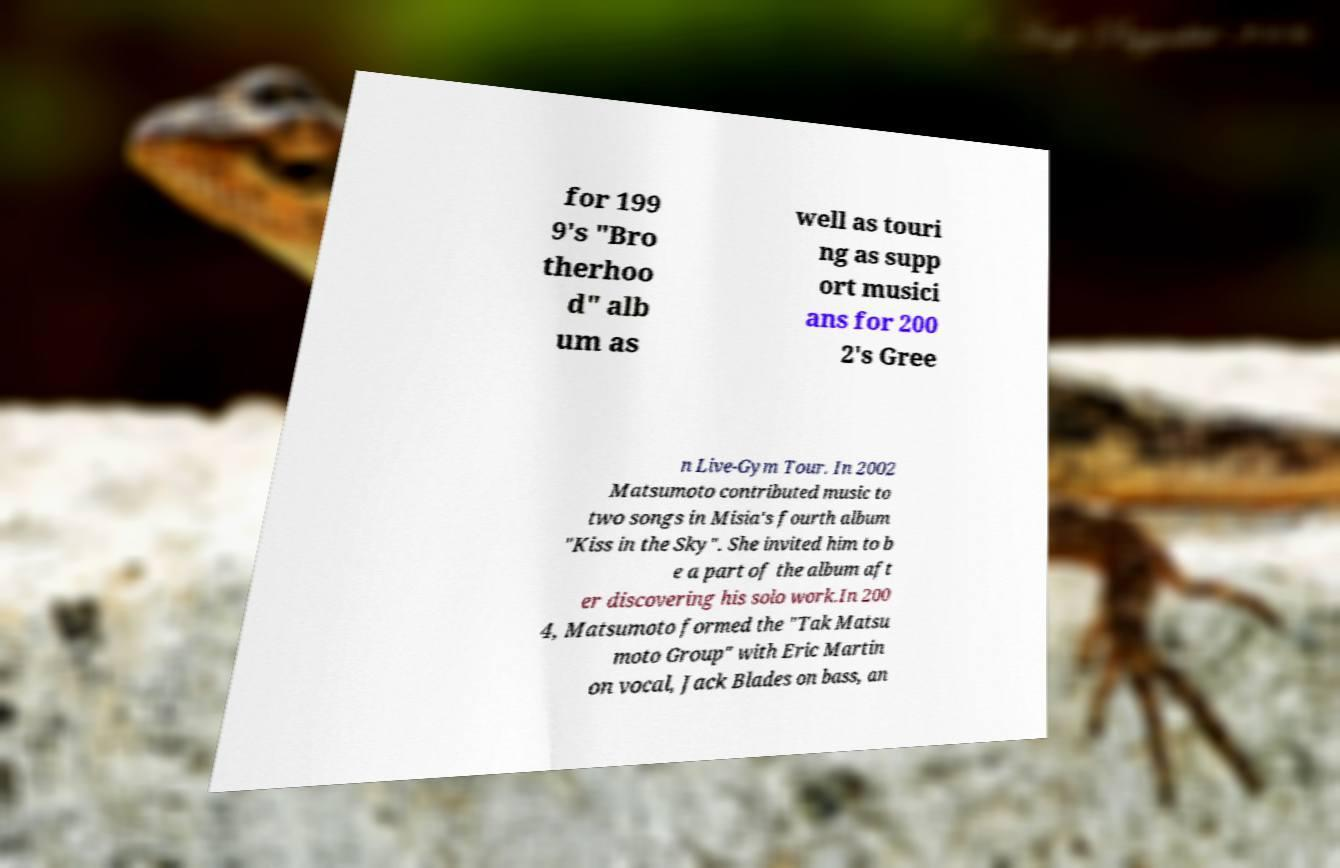Could you extract and type out the text from this image? for 199 9's "Bro therhoo d" alb um as well as touri ng as supp ort musici ans for 200 2's Gree n Live-Gym Tour. In 2002 Matsumoto contributed music to two songs in Misia's fourth album "Kiss in the Sky". She invited him to b e a part of the album aft er discovering his solo work.In 200 4, Matsumoto formed the "Tak Matsu moto Group" with Eric Martin on vocal, Jack Blades on bass, an 